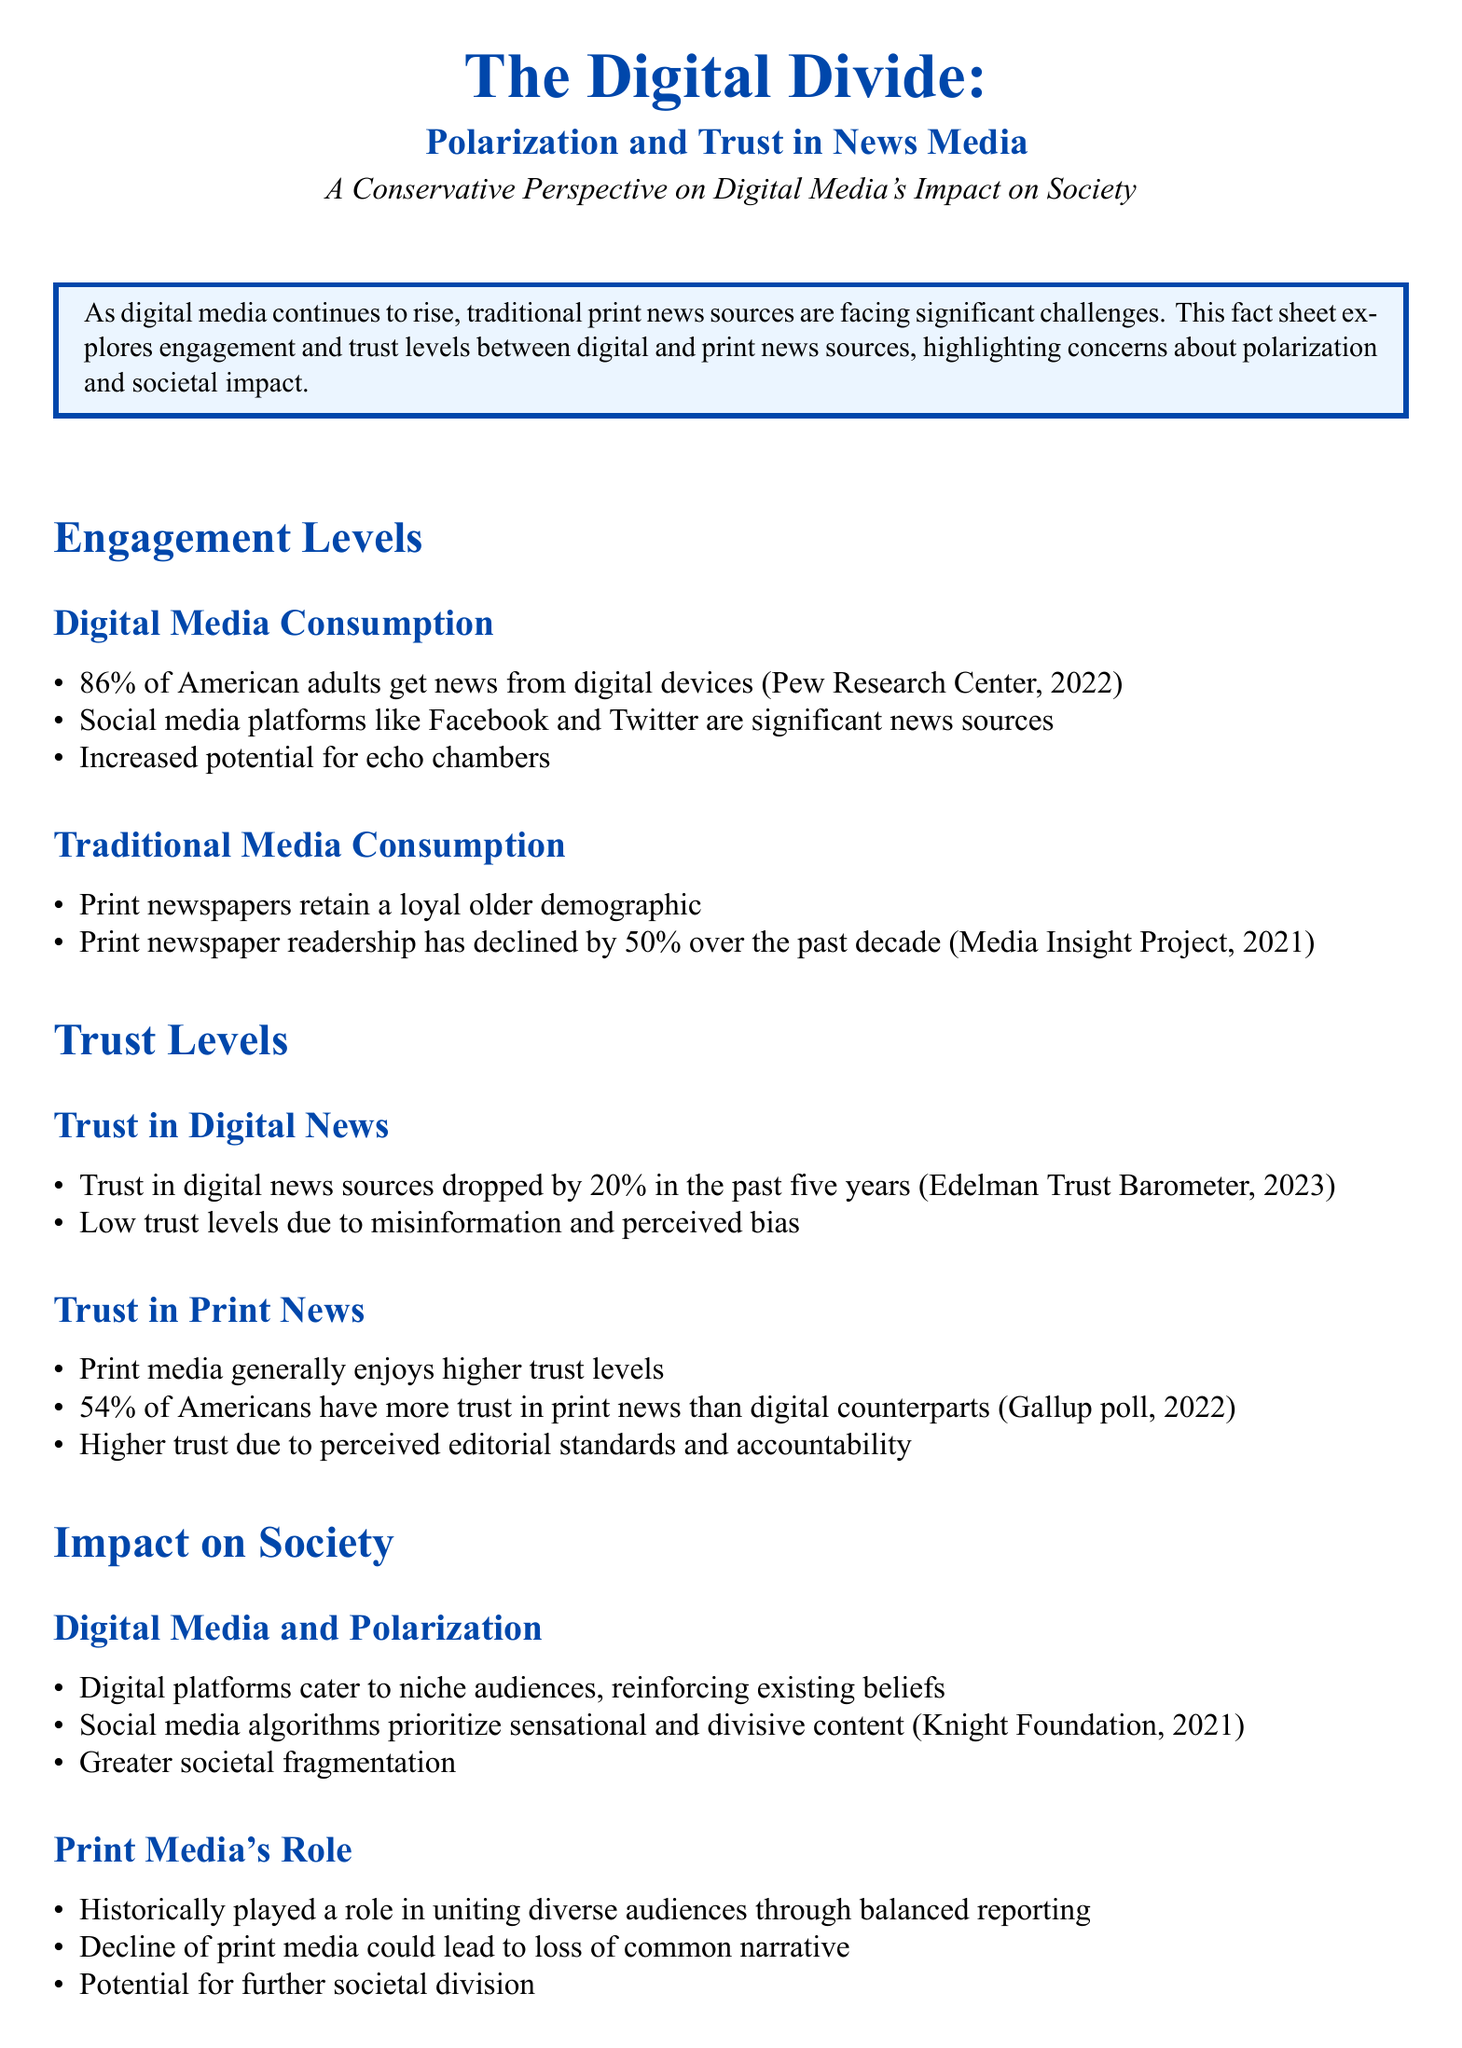What percentage of American adults get news from digital devices? The document states that 86% of American adults get news from digital devices according to Pew Research Center, 2022.
Answer: 86% What was the decline percentage of print newspaper readership over the past decade? The fact sheet mentions that print newspaper readership has declined by 50% over the past decade according to Media Insight Project, 2021.
Answer: 50% What percentage of Americans have more trust in print news than digital news? The Gallup poll, 2022 indicates that 54% of Americans have more trust in print news than digital counterparts.
Answer: 54% By what percentage did trust in digital news sources drop in the past five years? The document notes that trust in digital news sources dropped by 20% in the past five years as per the Edelman Trust Barometer, 2023.
Answer: 20% What factor contributes to low trust levels in digital news? The fact sheet mentions misinformation and perceived bias as factors contributing to low trust levels in digital news.
Answer: Misinformation and perceived bias Why is print media generally trusted more than digital media? The document suggests that higher trust in print media is due to perceived editorial standards and accountability.
Answer: Editorial standards and accountability What role has print media historically played in society? According to the document, print media has historically played a role in uniting diverse audiences through balanced reporting.
Answer: Uniting diverse audiences What impact do social media algorithms have on content? The fact sheet states that social media algorithms prioritize sensational and divisive content, contributing to societal fragmentation.
Answer: Prioritize sensational and divisive content What is the conclusion regarding the value of traditional print news? The conclusion indicates that traditional print news, with its higher trust levels and balanced reporting, still holds value in maintaining a cohesive society.
Answer: Holds value in maintaining a cohesive society 